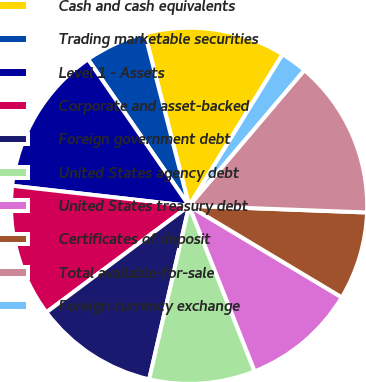<chart> <loc_0><loc_0><loc_500><loc_500><pie_chart><fcel>Cash and cash equivalents<fcel>Trading marketable securities<fcel>Level 1 - Assets<fcel>Corporate and asset-backed<fcel>Foreign government debt<fcel>United States agency debt<fcel>United States treasury debt<fcel>Certificates of deposit<fcel>Total available-for-sale<fcel>Foreign currency exchange<nl><fcel>12.8%<fcel>5.61%<fcel>13.59%<fcel>12.0%<fcel>11.2%<fcel>9.6%<fcel>10.4%<fcel>8.0%<fcel>14.39%<fcel>2.41%<nl></chart> 